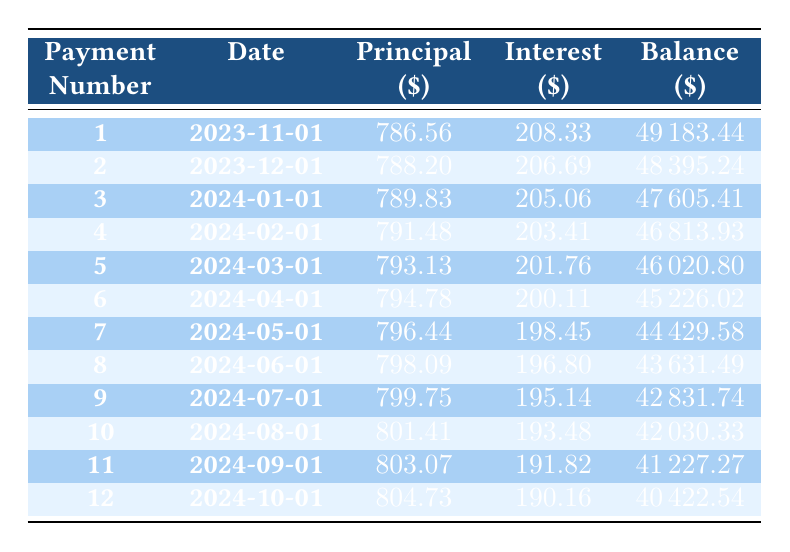What is the total amount of principal paid in the first three payments? The principal payments for the first three payments are: 786.56, 788.20, and 789.83. To find the total, we add these amounts: 786.56 + 788.20 + 789.83 = 2364.59.
Answer: 2364.59 What is the remaining balance after the second payment? According to the table, the remaining balance after the second payment is provided in the 'Balance' column for payment number 2, which is 48395.24.
Answer: 48395.24 Is the interest payment smaller in the second payment than in the first payment? From the table, the interest payment for the first payment is 208.33 and for the second payment is 206.69. Comparing these values shows that 206.69 is less than 208.33, so yes, the interest payment is smaller in the second payment.
Answer: Yes What is the average monthly principal payment for the first five months? The principal payments for the first five payments are 786.56, 788.20, 789.83, 791.48, and 793.13. To find the average, first, we sum these values: 786.56 + 788.20 + 789.83 + 791.48 + 793.13 = 3949.20, and then divide by 5: 3949.20 / 5 = 789.84.
Answer: 789.84 What is the total interest paid in the first month and the second month? The interest payments for the first and second months are 208.33 and 206.69, respectively. To find the total interest paid in these two months, we add them: 208.33 + 206.69 = 415.02.
Answer: 415.02 After the first payment, how much is left to pay off the loan? The remaining balance after the first payment is shown in the 'Balance' column, which is 49183.44. This amount reflects how much is left to pay off the loan after making the first payment.
Answer: 49183.44 Is the monthly payment of 943.56 consistent across all twelve payments? The monthly payment of 943.56 is noted as constant in the loan details, which suggests that it remains the same across all payments, thus confirming that it is consistent.
Answer: Yes How much less is the interest payment in the tenth month compared to the first month? The interest payment in the first month is 208.33, and in the tenth month, it is 193.48. To find the difference, we subtract the tenth month's payment from the first: 208.33 - 193.48 = 14.85.
Answer: 14.85 